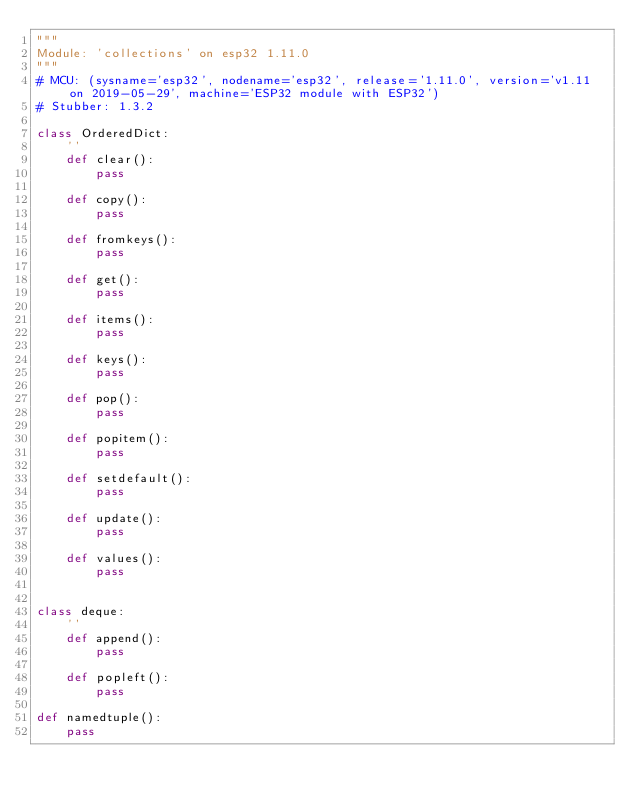Convert code to text. <code><loc_0><loc_0><loc_500><loc_500><_Python_>"""
Module: 'collections' on esp32 1.11.0
"""
# MCU: (sysname='esp32', nodename='esp32', release='1.11.0', version='v1.11 on 2019-05-29', machine='ESP32 module with ESP32')
# Stubber: 1.3.2

class OrderedDict:
    ''
    def clear():
        pass

    def copy():
        pass

    def fromkeys():
        pass

    def get():
        pass

    def items():
        pass

    def keys():
        pass

    def pop():
        pass

    def popitem():
        pass

    def setdefault():
        pass

    def update():
        pass

    def values():
        pass


class deque:
    ''
    def append():
        pass

    def popleft():
        pass

def namedtuple():
    pass

</code> 